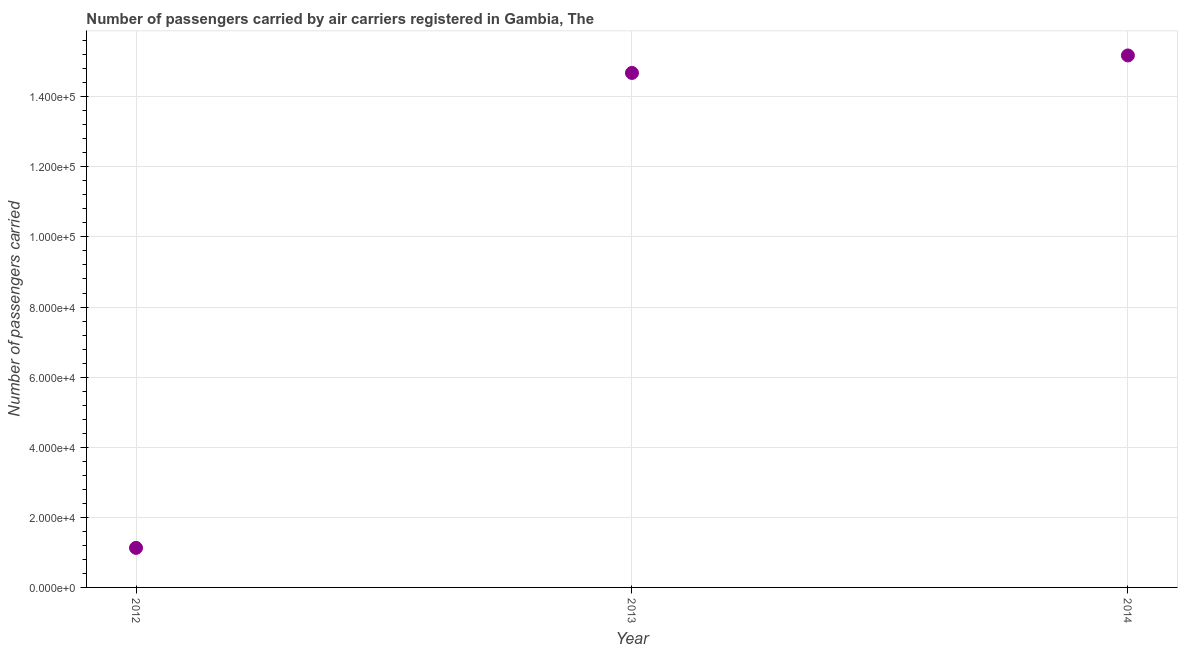What is the number of passengers carried in 2014?
Keep it short and to the point. 1.52e+05. Across all years, what is the maximum number of passengers carried?
Your answer should be compact. 1.52e+05. Across all years, what is the minimum number of passengers carried?
Offer a terse response. 1.13e+04. In which year was the number of passengers carried minimum?
Your response must be concise. 2012. What is the sum of the number of passengers carried?
Keep it short and to the point. 3.10e+05. What is the difference between the number of passengers carried in 2012 and 2014?
Keep it short and to the point. -1.40e+05. What is the average number of passengers carried per year?
Offer a terse response. 1.03e+05. What is the median number of passengers carried?
Offer a terse response. 1.47e+05. In how many years, is the number of passengers carried greater than 104000 ?
Give a very brief answer. 2. What is the ratio of the number of passengers carried in 2012 to that in 2014?
Keep it short and to the point. 0.07. Is the difference between the number of passengers carried in 2012 and 2014 greater than the difference between any two years?
Provide a succinct answer. Yes. What is the difference between the highest and the second highest number of passengers carried?
Give a very brief answer. 4990.75. What is the difference between the highest and the lowest number of passengers carried?
Provide a succinct answer. 1.40e+05. Does the number of passengers carried monotonically increase over the years?
Give a very brief answer. Yes. How many years are there in the graph?
Your response must be concise. 3. What is the difference between two consecutive major ticks on the Y-axis?
Provide a short and direct response. 2.00e+04. Are the values on the major ticks of Y-axis written in scientific E-notation?
Your answer should be very brief. Yes. Does the graph contain any zero values?
Provide a short and direct response. No. What is the title of the graph?
Ensure brevity in your answer.  Number of passengers carried by air carriers registered in Gambia, The. What is the label or title of the Y-axis?
Your answer should be very brief. Number of passengers carried. What is the Number of passengers carried in 2012?
Give a very brief answer. 1.13e+04. What is the Number of passengers carried in 2013?
Offer a terse response. 1.47e+05. What is the Number of passengers carried in 2014?
Your answer should be very brief. 1.52e+05. What is the difference between the Number of passengers carried in 2012 and 2013?
Your answer should be very brief. -1.36e+05. What is the difference between the Number of passengers carried in 2012 and 2014?
Give a very brief answer. -1.40e+05. What is the difference between the Number of passengers carried in 2013 and 2014?
Offer a very short reply. -4990.75. What is the ratio of the Number of passengers carried in 2012 to that in 2013?
Ensure brevity in your answer.  0.08. What is the ratio of the Number of passengers carried in 2012 to that in 2014?
Keep it short and to the point. 0.07. 